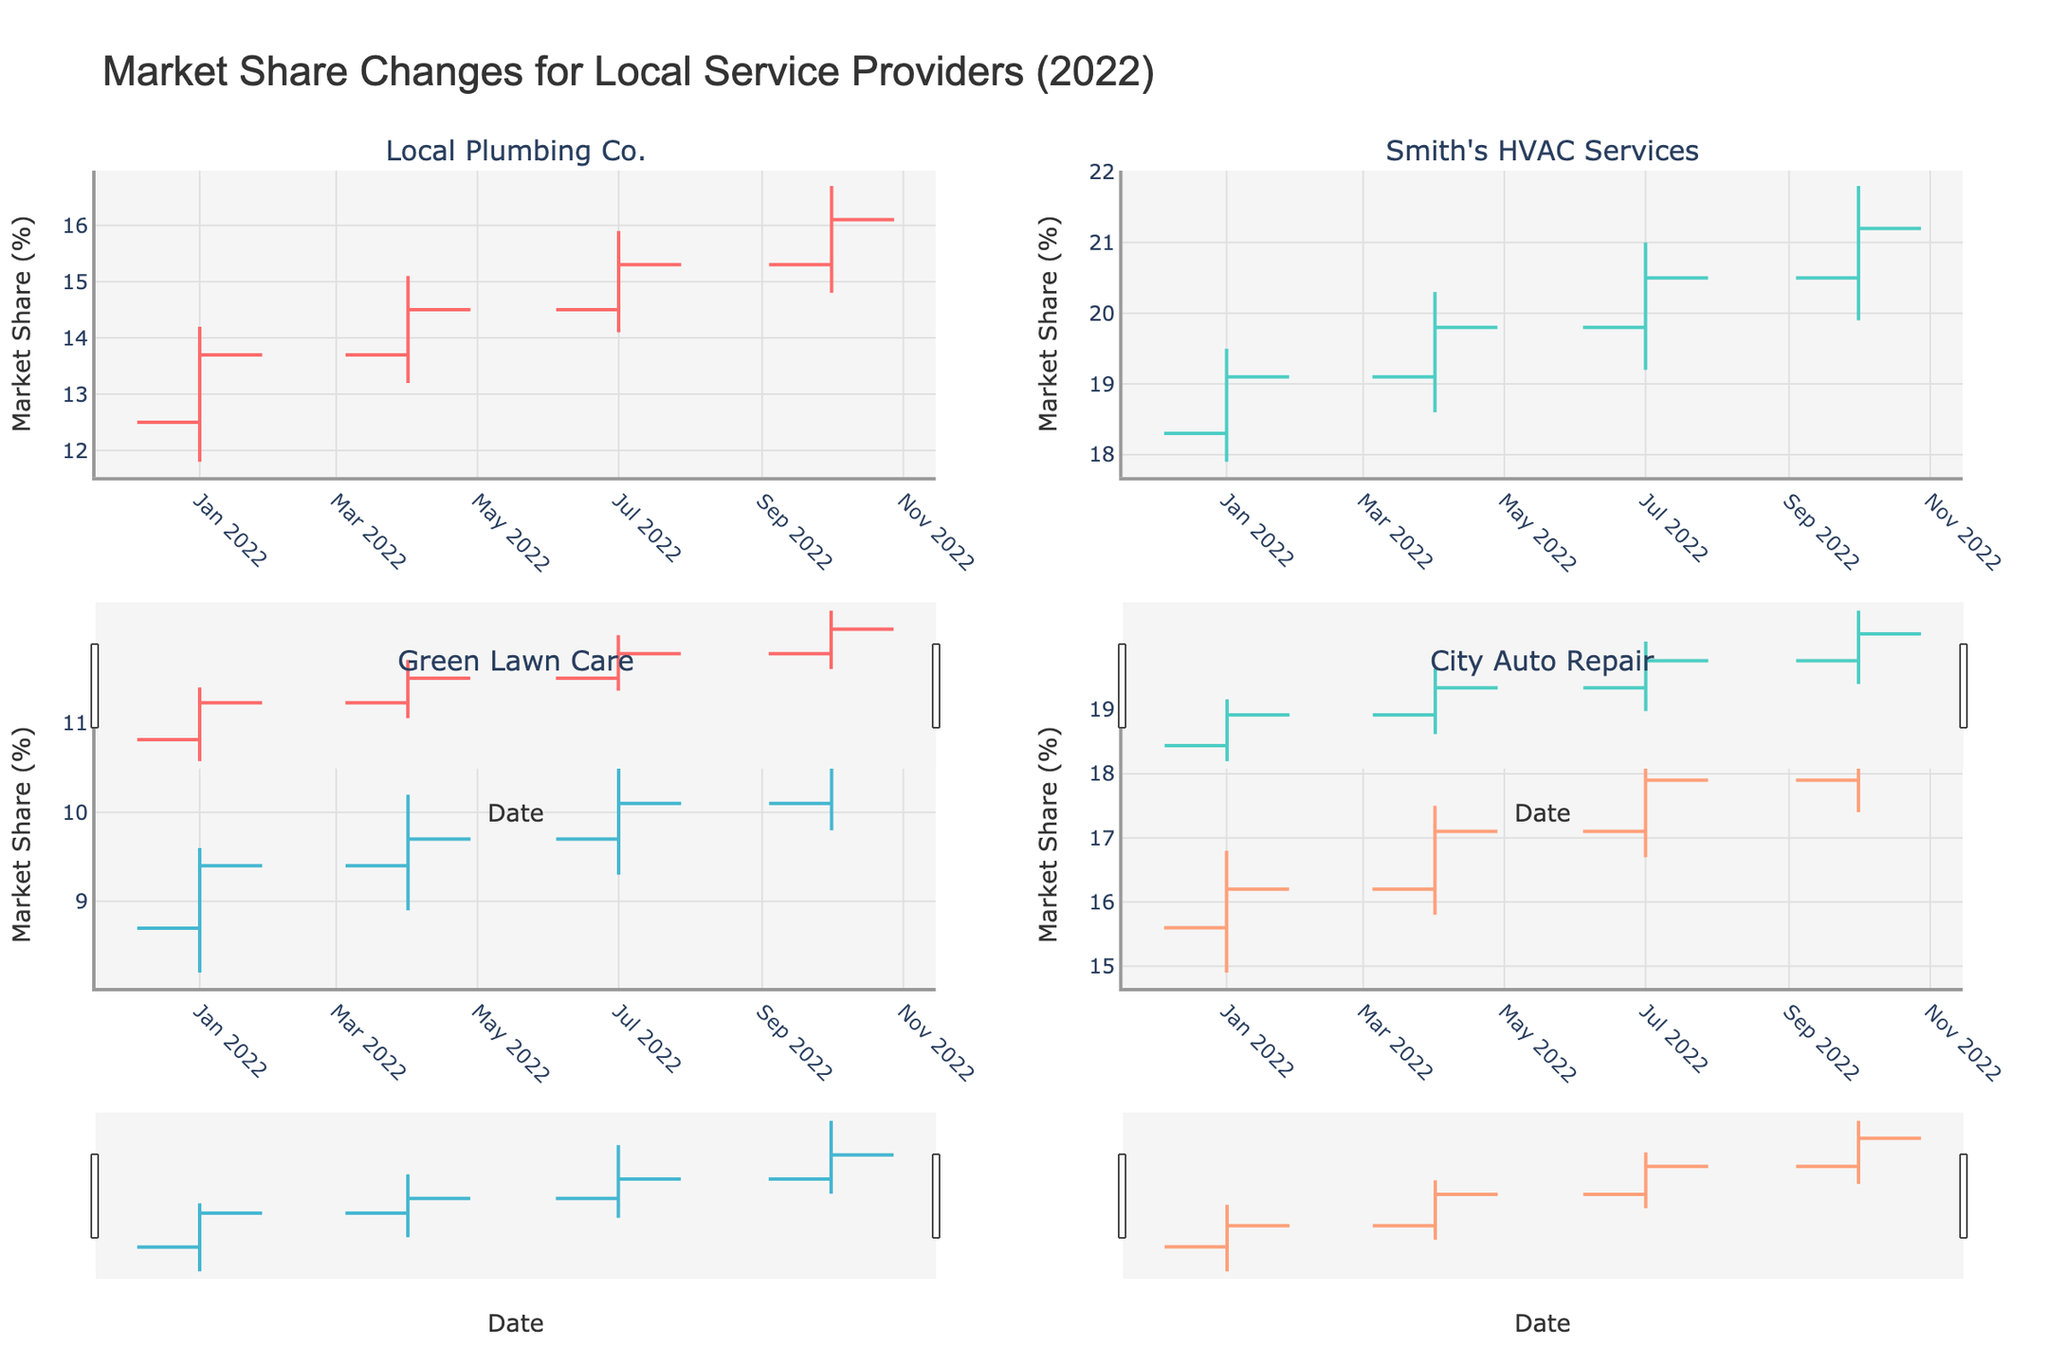What is the title of the figure? The title is usually displayed at the top of the figure. Here, it reads "Market Share Changes for Local Service Providers (2022)."
Answer: Market Share Changes for Local Service Providers (2022) How many data points are displayed for each provider? Each provider has data corresponding to the four quarters of 2022: January, April, July, and October. You can see four data points for each provider.
Answer: 4 Which provider shows the highest closing market share in January 2022? Look at the "Close" value for each provider's January data. Smith's HVAC Services has the highest closing value of 19.1.
Answer: Smith's HVAC Services Between which dates did Local Plumbing Co.'s market share increase for three consecutive quarters? Look at the "Close" values for Local Plumbing Co. across different dates. The "Close" values increase from January to April, April to July, and July to October.
Answer: January to October What is the difference between the highest and lowest market share for Green Lawn Care in 2022? Green Lawn Care's highest "High" value is 11.3 (October) and its lowest "Low" value is 8.2 (January). The difference is 11.3 - 8.2.
Answer: 3.1 Which quarter shows the largest increase in market share for City Auto Repair? Calculate the difference between "Close" and "Open" values for each quarter. In April, the difference is the largest, with 17.1 - 16.2 = 0.9.
Answer: April Compare the closing values in October for all providers. Who had the lowest market share? Compare the "Close" values for October. Green Lawn Care has the lowest value with 10.6.
Answer: Green Lawn Care What was the median closing value for Smith’s HVAC Services across all quarters? The "Close" values for Smith's HVAC Services are 19.1, 19.8, 20.5, and 21.2. The median of these values (sorted: 19.1, 19.8, 20.5, 21.2) is the average of 19.8 and 20.5.
Answer: 20.15 What color represents the increasing trend for Local Plumbing Co.? The increasing trend for each provider has a specific color. Local Plumbing Co. shows red lines for increasing trends.
Answer: Red Between Smith's HVAC Services and City Auto Repair, who had a higher closing value in July 2022? Compare the "Close" values for July. Smith's HVAC Services has 20.5 and City Auto Repair has 17.9. Smith's HVAC Services is higher.
Answer: Smith's HVAC Services 